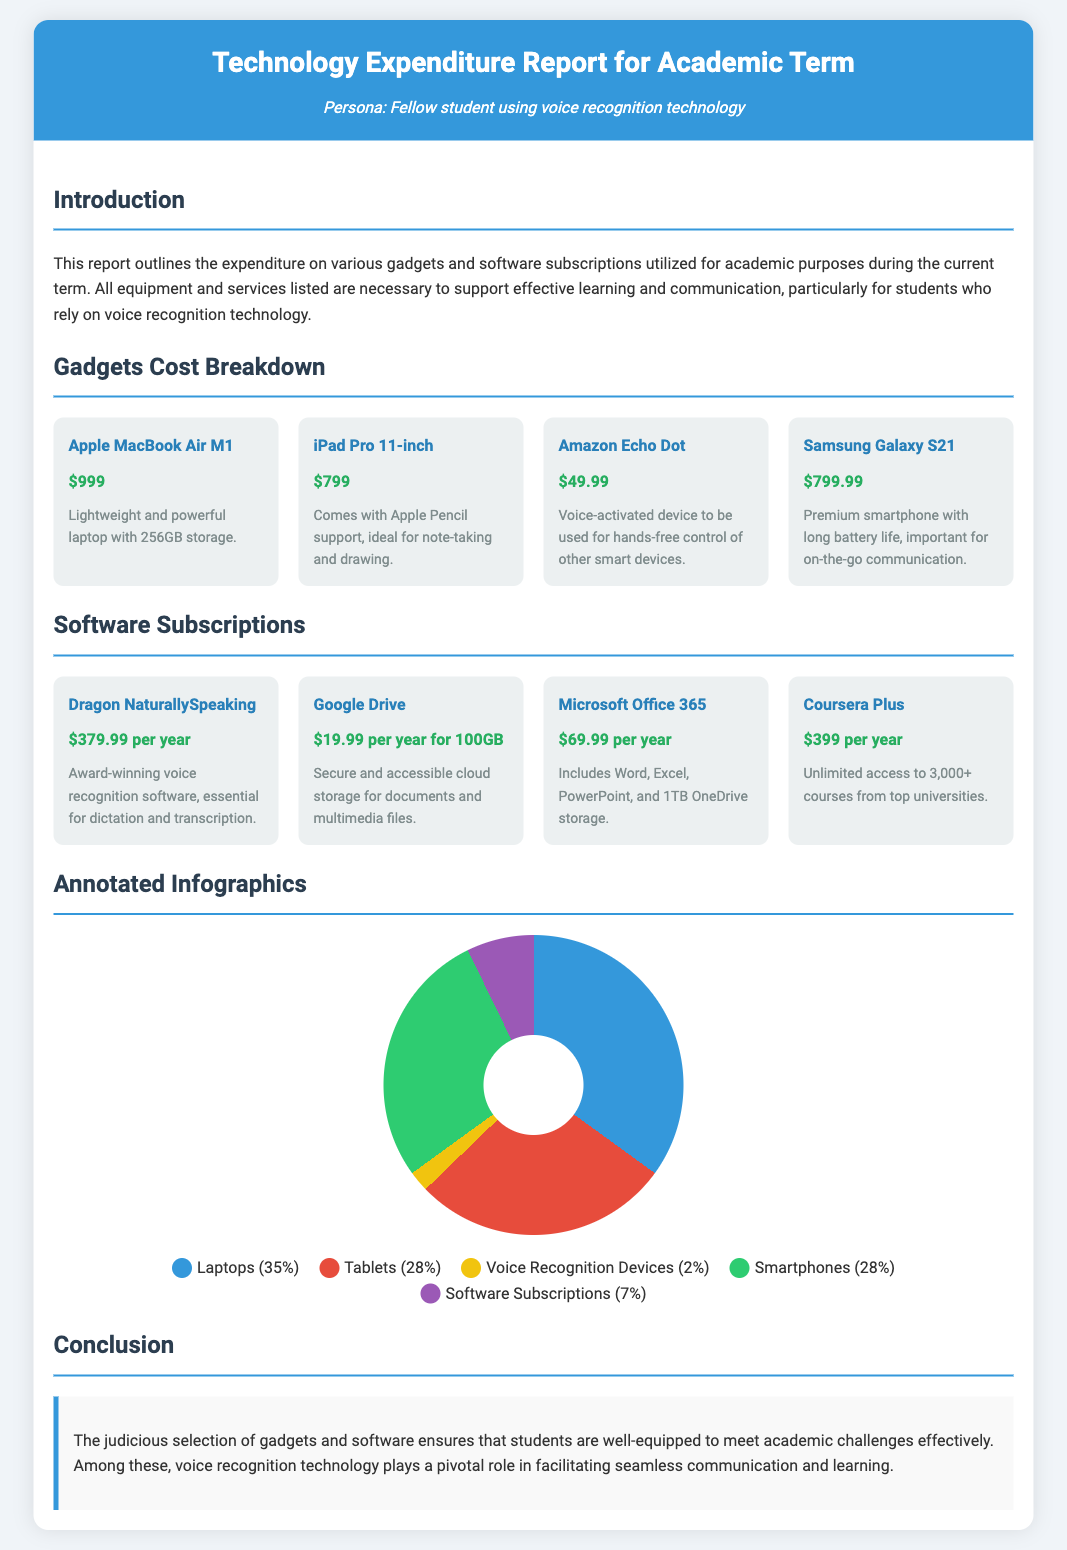What is the title of the report? The title clearly stated at the top of the document is "Technology Expenditure Report for Academic Term."
Answer: Technology Expenditure Report for Academic Term How much does the iPad Pro cost? The specific cost for the iPad Pro stated in the document is $799.
Answer: $799 What percentage of the budget is allocated to software subscriptions? The document lists software subscriptions as 7% of the total budget in the pie chart legend.
Answer: 7% Which gadget costs the least? The gadget with the lowest price listed in the expenditure section is the Amazon Echo Dot costing $49.99.
Answer: $49.99 What is the total cost of the Apple MacBook Air M1 and the Samsung Galaxy S21? The total cost is calculated by adding the price of the Apple MacBook Air M1, which is $999, and the Samsung Galaxy S21, which is $799.
Answer: $1798 What is the price of Dragon NaturallySpeaking per year? The annual subscription cost for Dragon NaturallySpeaking is explicitly indicated as $379.99 per year in the software section.
Answer: $379.99 per year How many gadgets are listed in the report? The gadget section contains a total of four items as represented in the grid layout.
Answer: 4 What is the primary technology highlighted for aiding communication? The document emphasizes the importance of voice recognition technology for facilitating communication.
Answer: Voice recognition technology What type of document is this? The document serves as a report that details expenditures for academic technology used by students.
Answer: Report 